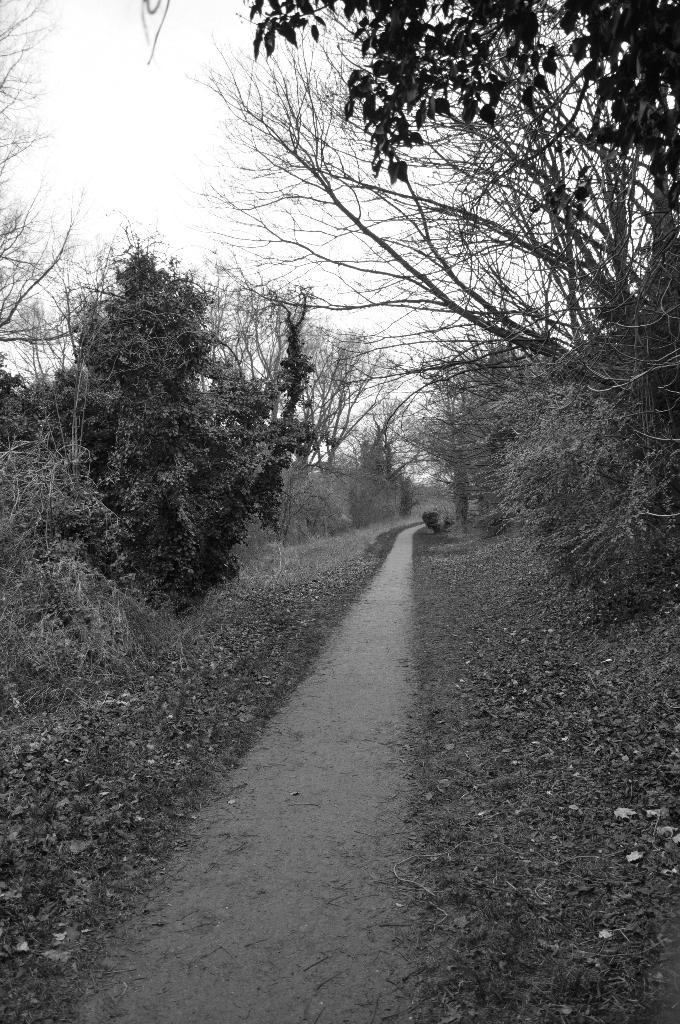What is the color scheme of the image? The image is black and white. What can be seen in the middle of the image? There is an empty road in the middle of the image. What type of vegetation is present in the image? There are trees and plants in the image. What type of waste can be seen in the image? There is no waste present in the image; it features an empty road, trees, and plants. What is being served for dinner in the image? There is no dinner or food present in the image. 